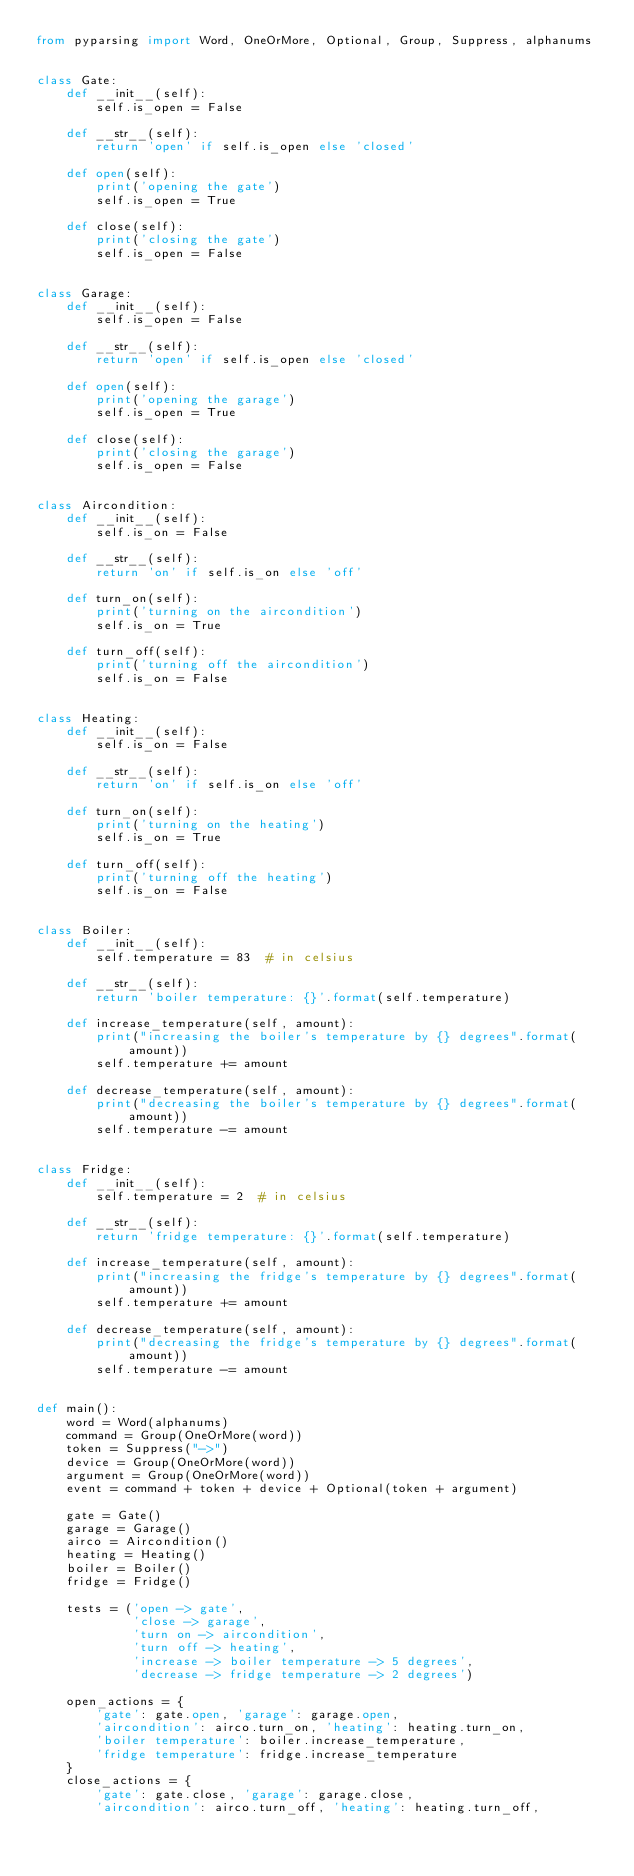<code> <loc_0><loc_0><loc_500><loc_500><_Python_>from pyparsing import Word, OneOrMore, Optional, Group, Suppress, alphanums


class Gate:
    def __init__(self):
        self.is_open = False

    def __str__(self):
        return 'open' if self.is_open else 'closed'

    def open(self):
        print('opening the gate')
        self.is_open = True

    def close(self):
        print('closing the gate')
        self.is_open = False


class Garage:
    def __init__(self):
        self.is_open = False

    def __str__(self):
        return 'open' if self.is_open else 'closed'

    def open(self):
        print('opening the garage')
        self.is_open = True

    def close(self):
        print('closing the garage')
        self.is_open = False


class Aircondition:
    def __init__(self):
        self.is_on = False

    def __str__(self):
        return 'on' if self.is_on else 'off'

    def turn_on(self):
        print('turning on the aircondition')
        self.is_on = True

    def turn_off(self):
        print('turning off the aircondition')
        self.is_on = False


class Heating:
    def __init__(self):
        self.is_on = False

    def __str__(self):
        return 'on' if self.is_on else 'off'

    def turn_on(self):
        print('turning on the heating')
        self.is_on = True

    def turn_off(self):
        print('turning off the heating')
        self.is_on = False


class Boiler:
    def __init__(self):
        self.temperature = 83  # in celsius

    def __str__(self):
        return 'boiler temperature: {}'.format(self.temperature)

    def increase_temperature(self, amount):
        print("increasing the boiler's temperature by {} degrees".format(amount))
        self.temperature += amount

    def decrease_temperature(self, amount):
        print("decreasing the boiler's temperature by {} degrees".format(amount))
        self.temperature -= amount


class Fridge:
    def __init__(self):
        self.temperature = 2  # in celsius

    def __str__(self):
        return 'fridge temperature: {}'.format(self.temperature)

    def increase_temperature(self, amount):
        print("increasing the fridge's temperature by {} degrees".format(amount))
        self.temperature += amount

    def decrease_temperature(self, amount):
        print("decreasing the fridge's temperature by {} degrees".format(amount))
        self.temperature -= amount


def main():
    word = Word(alphanums)
    command = Group(OneOrMore(word))
    token = Suppress("->")
    device = Group(OneOrMore(word))
    argument = Group(OneOrMore(word))
    event = command + token + device + Optional(token + argument)

    gate = Gate()
    garage = Garage()
    airco = Aircondition()
    heating = Heating()
    boiler = Boiler()
    fridge = Fridge()

    tests = ('open -> gate',
             'close -> garage',
             'turn on -> aircondition',
             'turn off -> heating',
             'increase -> boiler temperature -> 5 degrees',
             'decrease -> fridge temperature -> 2 degrees')

    open_actions = {
        'gate': gate.open, 'garage': garage.open,
        'aircondition': airco.turn_on, 'heating': heating.turn_on,
        'boiler temperature': boiler.increase_temperature,
        'fridge temperature': fridge.increase_temperature
    }
    close_actions = {
        'gate': gate.close, 'garage': garage.close,
        'aircondition': airco.turn_off, 'heating': heating.turn_off,</code> 